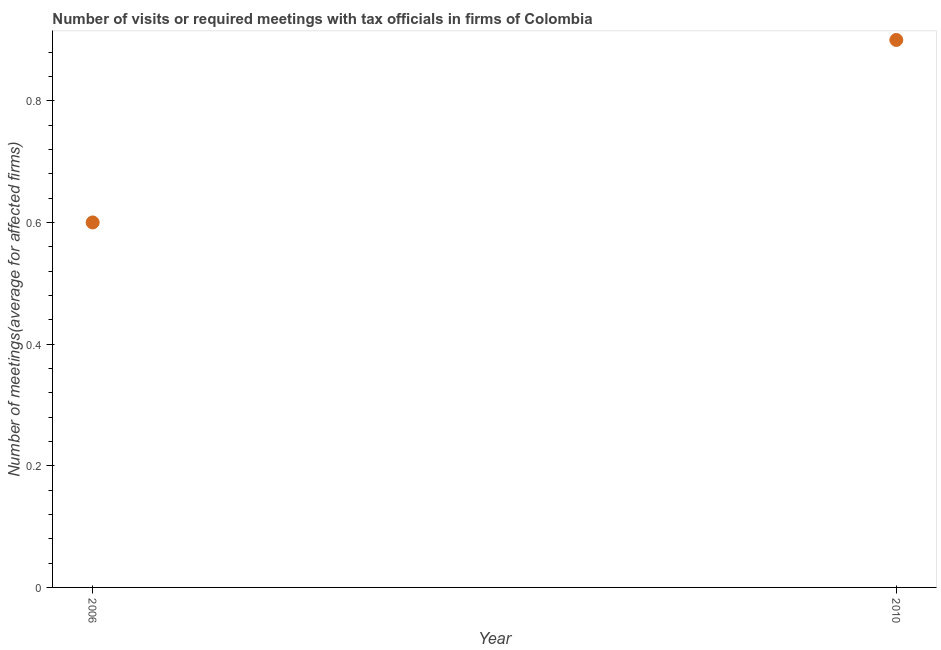Across all years, what is the minimum number of required meetings with tax officials?
Your answer should be compact. 0.6. In which year was the number of required meetings with tax officials maximum?
Offer a very short reply. 2010. In which year was the number of required meetings with tax officials minimum?
Give a very brief answer. 2006. What is the difference between the number of required meetings with tax officials in 2006 and 2010?
Offer a terse response. -0.3. In how many years, is the number of required meetings with tax officials greater than 0.8400000000000001 ?
Your response must be concise. 1. What is the ratio of the number of required meetings with tax officials in 2006 to that in 2010?
Keep it short and to the point. 0.67. Is the number of required meetings with tax officials in 2006 less than that in 2010?
Give a very brief answer. Yes. In how many years, is the number of required meetings with tax officials greater than the average number of required meetings with tax officials taken over all years?
Provide a short and direct response. 1. How many dotlines are there?
Your answer should be very brief. 1. How many years are there in the graph?
Provide a short and direct response. 2. What is the difference between two consecutive major ticks on the Y-axis?
Offer a very short reply. 0.2. Does the graph contain grids?
Give a very brief answer. No. What is the title of the graph?
Provide a short and direct response. Number of visits or required meetings with tax officials in firms of Colombia. What is the label or title of the Y-axis?
Provide a succinct answer. Number of meetings(average for affected firms). What is the Number of meetings(average for affected firms) in 2006?
Your answer should be compact. 0.6. What is the Number of meetings(average for affected firms) in 2010?
Provide a short and direct response. 0.9. What is the difference between the Number of meetings(average for affected firms) in 2006 and 2010?
Your answer should be compact. -0.3. What is the ratio of the Number of meetings(average for affected firms) in 2006 to that in 2010?
Give a very brief answer. 0.67. 